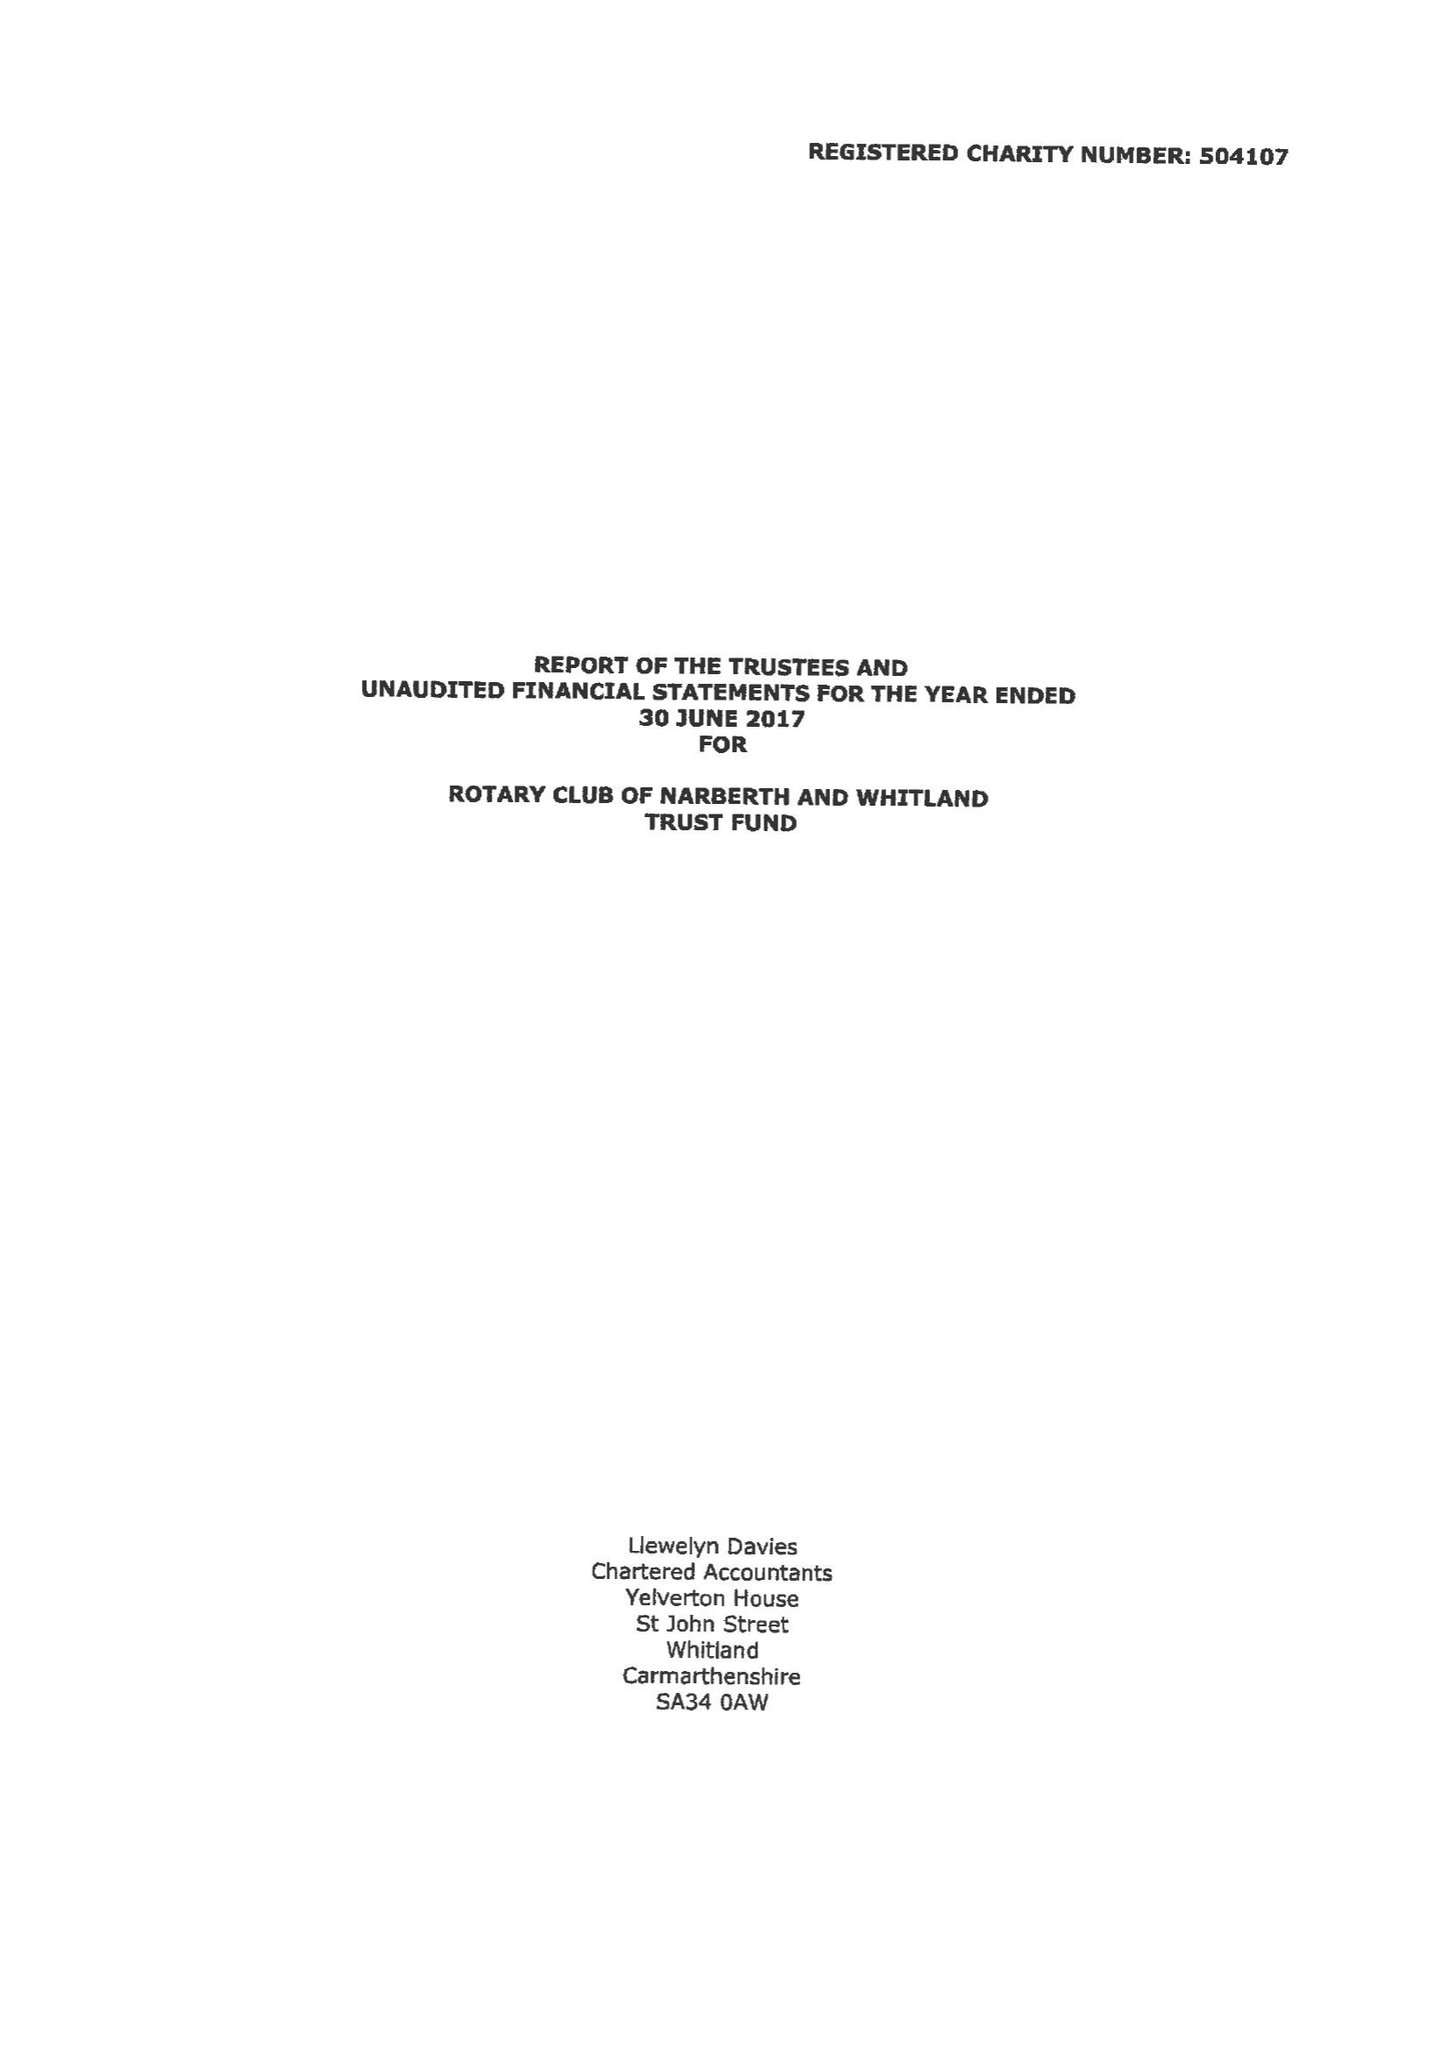What is the value for the report_date?
Answer the question using a single word or phrase. 2017-06-30 